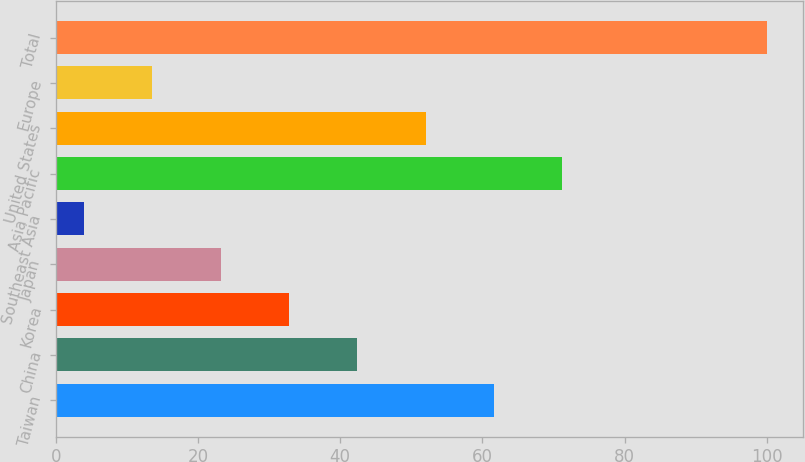<chart> <loc_0><loc_0><loc_500><loc_500><bar_chart><fcel>Taiwan<fcel>China<fcel>Korea<fcel>Japan<fcel>Southeast Asia<fcel>Asia Pacific<fcel>United States<fcel>Europe<fcel>Total<nl><fcel>61.6<fcel>42.4<fcel>32.8<fcel>23.2<fcel>4<fcel>71.2<fcel>52<fcel>13.6<fcel>100<nl></chart> 